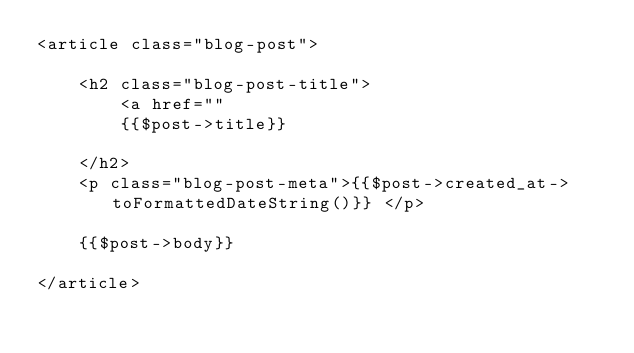Convert code to text. <code><loc_0><loc_0><loc_500><loc_500><_PHP_><article class="blog-post">

    <h2 class="blog-post-title">
        <a href=""
        {{$post->title}}
    
    </h2>
    <p class="blog-post-meta">{{$post->created_at->toFormattedDateString()}} </p>
        
    {{$post->body}}

</article>        </code> 